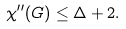<formula> <loc_0><loc_0><loc_500><loc_500>\chi ^ { \prime \prime } ( G ) \leq \Delta + 2 .</formula> 